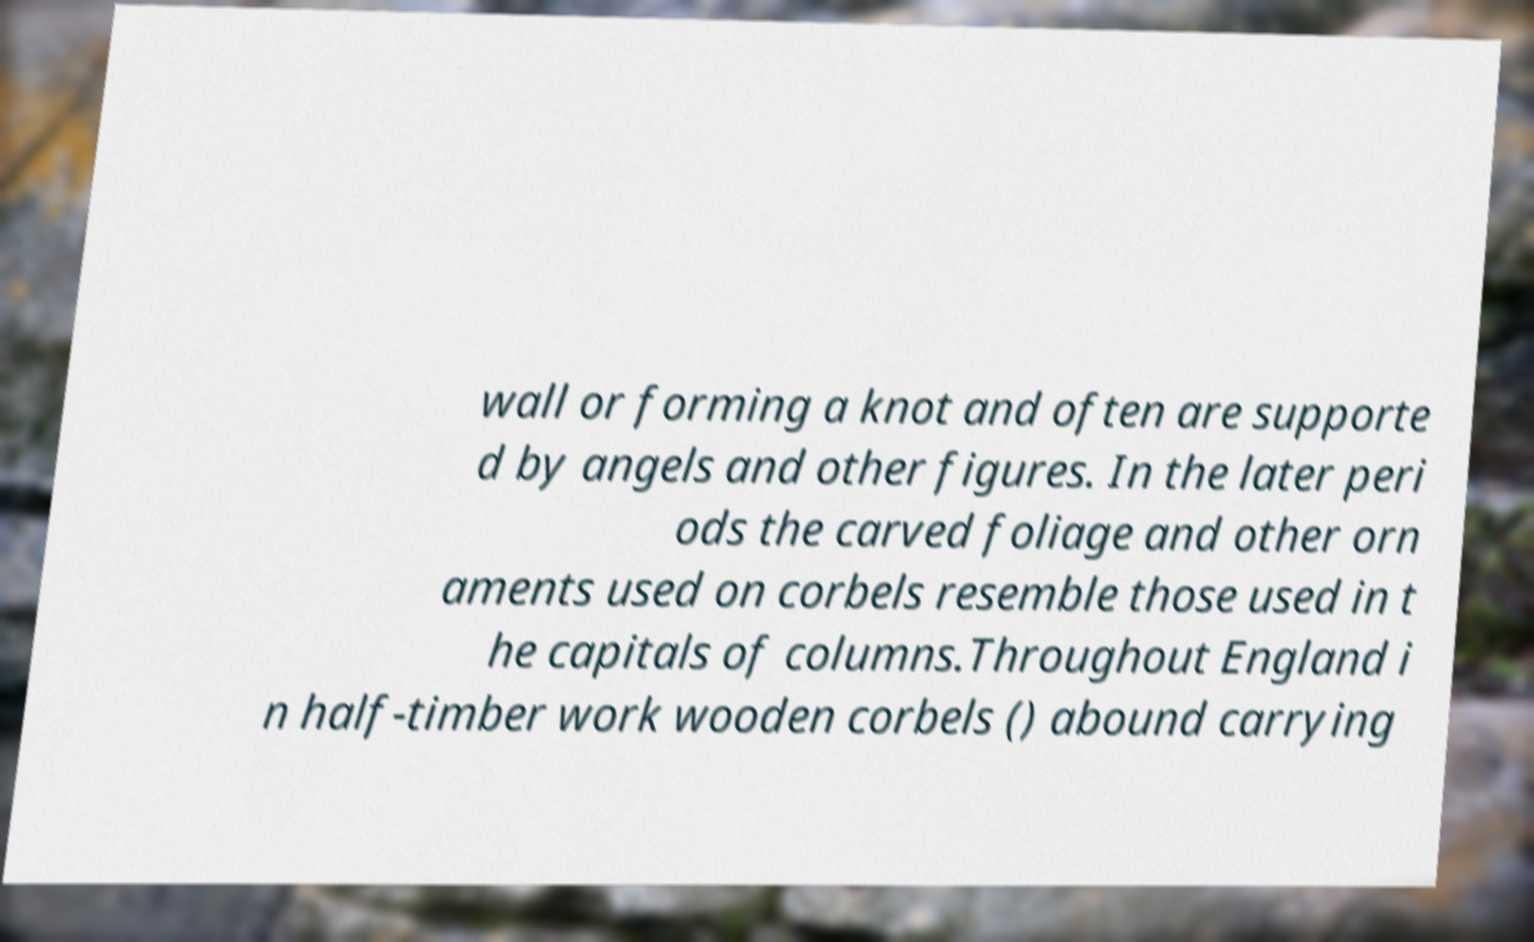Please identify and transcribe the text found in this image. wall or forming a knot and often are supporte d by angels and other figures. In the later peri ods the carved foliage and other orn aments used on corbels resemble those used in t he capitals of columns.Throughout England i n half-timber work wooden corbels () abound carrying 